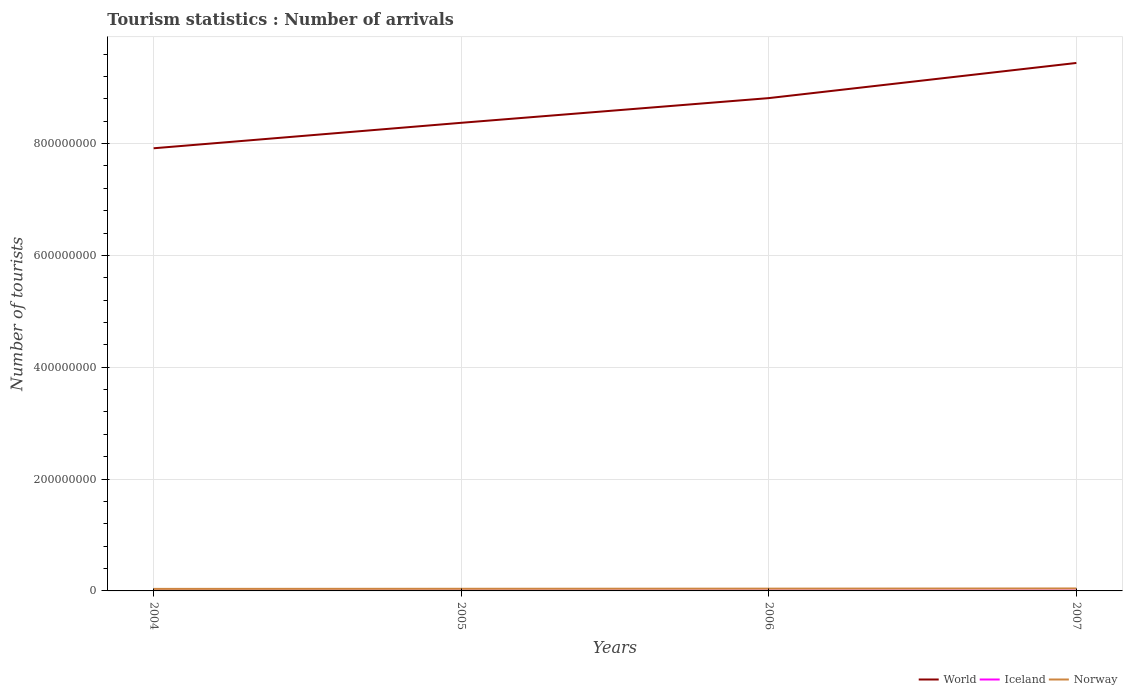How many different coloured lines are there?
Make the answer very short. 3. Across all years, what is the maximum number of tourist arrivals in Norway?
Your answer should be very brief. 3.63e+06. What is the total number of tourist arrivals in World in the graph?
Provide a succinct answer. -4.55e+07. What is the difference between the highest and the second highest number of tourist arrivals in Iceland?
Provide a short and direct response. 1.25e+05. Is the number of tourist arrivals in Iceland strictly greater than the number of tourist arrivals in World over the years?
Offer a very short reply. Yes. How many lines are there?
Offer a terse response. 3. How many years are there in the graph?
Provide a short and direct response. 4. What is the difference between two consecutive major ticks on the Y-axis?
Give a very brief answer. 2.00e+08. Are the values on the major ticks of Y-axis written in scientific E-notation?
Your answer should be very brief. No. Does the graph contain any zero values?
Make the answer very short. No. Where does the legend appear in the graph?
Ensure brevity in your answer.  Bottom right. How many legend labels are there?
Your response must be concise. 3. What is the title of the graph?
Provide a short and direct response. Tourism statistics : Number of arrivals. What is the label or title of the X-axis?
Your answer should be compact. Years. What is the label or title of the Y-axis?
Your response must be concise. Number of tourists. What is the Number of tourists in World in 2004?
Give a very brief answer. 7.92e+08. What is the Number of tourists in Norway in 2004?
Keep it short and to the point. 3.63e+06. What is the Number of tourists in World in 2005?
Your answer should be compact. 8.37e+08. What is the Number of tourists of Iceland in 2005?
Provide a succinct answer. 3.74e+05. What is the Number of tourists in Norway in 2005?
Offer a very short reply. 3.82e+06. What is the Number of tourists of World in 2006?
Ensure brevity in your answer.  8.81e+08. What is the Number of tourists of Iceland in 2006?
Make the answer very short. 4.22e+05. What is the Number of tourists of Norway in 2006?
Give a very brief answer. 4.07e+06. What is the Number of tourists of World in 2007?
Give a very brief answer. 9.44e+08. What is the Number of tourists in Iceland in 2007?
Your answer should be very brief. 4.85e+05. What is the Number of tourists in Norway in 2007?
Your answer should be compact. 4.38e+06. Across all years, what is the maximum Number of tourists of World?
Keep it short and to the point. 9.44e+08. Across all years, what is the maximum Number of tourists of Iceland?
Offer a very short reply. 4.85e+05. Across all years, what is the maximum Number of tourists in Norway?
Offer a terse response. 4.38e+06. Across all years, what is the minimum Number of tourists of World?
Offer a very short reply. 7.92e+08. Across all years, what is the minimum Number of tourists of Norway?
Offer a terse response. 3.63e+06. What is the total Number of tourists in World in the graph?
Give a very brief answer. 3.45e+09. What is the total Number of tourists of Iceland in the graph?
Give a very brief answer. 1.64e+06. What is the total Number of tourists in Norway in the graph?
Keep it short and to the point. 1.59e+07. What is the difference between the Number of tourists of World in 2004 and that in 2005?
Your answer should be compact. -4.55e+07. What is the difference between the Number of tourists of Iceland in 2004 and that in 2005?
Give a very brief answer. -1.40e+04. What is the difference between the Number of tourists of Norway in 2004 and that in 2005?
Ensure brevity in your answer.  -1.96e+05. What is the difference between the Number of tourists of World in 2004 and that in 2006?
Give a very brief answer. -8.97e+07. What is the difference between the Number of tourists of Iceland in 2004 and that in 2006?
Your answer should be compact. -6.20e+04. What is the difference between the Number of tourists in Norway in 2004 and that in 2006?
Provide a succinct answer. -4.42e+05. What is the difference between the Number of tourists in World in 2004 and that in 2007?
Make the answer very short. -1.53e+08. What is the difference between the Number of tourists in Iceland in 2004 and that in 2007?
Provide a succinct answer. -1.25e+05. What is the difference between the Number of tourists of Norway in 2004 and that in 2007?
Ensure brevity in your answer.  -7.49e+05. What is the difference between the Number of tourists in World in 2005 and that in 2006?
Give a very brief answer. -4.42e+07. What is the difference between the Number of tourists of Iceland in 2005 and that in 2006?
Ensure brevity in your answer.  -4.80e+04. What is the difference between the Number of tourists of Norway in 2005 and that in 2006?
Provide a short and direct response. -2.46e+05. What is the difference between the Number of tourists of World in 2005 and that in 2007?
Your answer should be very brief. -1.07e+08. What is the difference between the Number of tourists in Iceland in 2005 and that in 2007?
Provide a succinct answer. -1.11e+05. What is the difference between the Number of tourists of Norway in 2005 and that in 2007?
Ensure brevity in your answer.  -5.53e+05. What is the difference between the Number of tourists in World in 2006 and that in 2007?
Your response must be concise. -6.29e+07. What is the difference between the Number of tourists in Iceland in 2006 and that in 2007?
Ensure brevity in your answer.  -6.30e+04. What is the difference between the Number of tourists in Norway in 2006 and that in 2007?
Offer a very short reply. -3.07e+05. What is the difference between the Number of tourists in World in 2004 and the Number of tourists in Iceland in 2005?
Offer a very short reply. 7.91e+08. What is the difference between the Number of tourists of World in 2004 and the Number of tourists of Norway in 2005?
Give a very brief answer. 7.88e+08. What is the difference between the Number of tourists of Iceland in 2004 and the Number of tourists of Norway in 2005?
Provide a succinct answer. -3.46e+06. What is the difference between the Number of tourists of World in 2004 and the Number of tourists of Iceland in 2006?
Provide a short and direct response. 7.91e+08. What is the difference between the Number of tourists of World in 2004 and the Number of tourists of Norway in 2006?
Offer a very short reply. 7.88e+08. What is the difference between the Number of tourists of Iceland in 2004 and the Number of tourists of Norway in 2006?
Your answer should be very brief. -3.71e+06. What is the difference between the Number of tourists of World in 2004 and the Number of tourists of Iceland in 2007?
Your response must be concise. 7.91e+08. What is the difference between the Number of tourists in World in 2004 and the Number of tourists in Norway in 2007?
Keep it short and to the point. 7.87e+08. What is the difference between the Number of tourists in Iceland in 2004 and the Number of tourists in Norway in 2007?
Offer a very short reply. -4.02e+06. What is the difference between the Number of tourists in World in 2005 and the Number of tourists in Iceland in 2006?
Your answer should be compact. 8.37e+08. What is the difference between the Number of tourists of World in 2005 and the Number of tourists of Norway in 2006?
Give a very brief answer. 8.33e+08. What is the difference between the Number of tourists of Iceland in 2005 and the Number of tourists of Norway in 2006?
Make the answer very short. -3.70e+06. What is the difference between the Number of tourists of World in 2005 and the Number of tourists of Iceland in 2007?
Offer a terse response. 8.37e+08. What is the difference between the Number of tourists in World in 2005 and the Number of tourists in Norway in 2007?
Make the answer very short. 8.33e+08. What is the difference between the Number of tourists of Iceland in 2005 and the Number of tourists of Norway in 2007?
Offer a very short reply. -4.00e+06. What is the difference between the Number of tourists in World in 2006 and the Number of tourists in Iceland in 2007?
Offer a very short reply. 8.81e+08. What is the difference between the Number of tourists of World in 2006 and the Number of tourists of Norway in 2007?
Provide a short and direct response. 8.77e+08. What is the difference between the Number of tourists in Iceland in 2006 and the Number of tourists in Norway in 2007?
Give a very brief answer. -3.96e+06. What is the average Number of tourists in World per year?
Offer a very short reply. 8.64e+08. What is the average Number of tourists of Iceland per year?
Provide a succinct answer. 4.10e+05. What is the average Number of tourists in Norway per year?
Provide a succinct answer. 3.97e+06. In the year 2004, what is the difference between the Number of tourists in World and Number of tourists in Iceland?
Give a very brief answer. 7.91e+08. In the year 2004, what is the difference between the Number of tourists of World and Number of tourists of Norway?
Your answer should be very brief. 7.88e+08. In the year 2004, what is the difference between the Number of tourists of Iceland and Number of tourists of Norway?
Your answer should be compact. -3.27e+06. In the year 2005, what is the difference between the Number of tourists of World and Number of tourists of Iceland?
Offer a very short reply. 8.37e+08. In the year 2005, what is the difference between the Number of tourists of World and Number of tourists of Norway?
Keep it short and to the point. 8.33e+08. In the year 2005, what is the difference between the Number of tourists in Iceland and Number of tourists in Norway?
Provide a succinct answer. -3.45e+06. In the year 2006, what is the difference between the Number of tourists of World and Number of tourists of Iceland?
Ensure brevity in your answer.  8.81e+08. In the year 2006, what is the difference between the Number of tourists of World and Number of tourists of Norway?
Offer a very short reply. 8.77e+08. In the year 2006, what is the difference between the Number of tourists of Iceland and Number of tourists of Norway?
Your response must be concise. -3.65e+06. In the year 2007, what is the difference between the Number of tourists of World and Number of tourists of Iceland?
Give a very brief answer. 9.44e+08. In the year 2007, what is the difference between the Number of tourists of World and Number of tourists of Norway?
Give a very brief answer. 9.40e+08. In the year 2007, what is the difference between the Number of tourists in Iceland and Number of tourists in Norway?
Provide a succinct answer. -3.89e+06. What is the ratio of the Number of tourists of World in 2004 to that in 2005?
Give a very brief answer. 0.95. What is the ratio of the Number of tourists of Iceland in 2004 to that in 2005?
Your answer should be very brief. 0.96. What is the ratio of the Number of tourists in Norway in 2004 to that in 2005?
Your answer should be compact. 0.95. What is the ratio of the Number of tourists of World in 2004 to that in 2006?
Give a very brief answer. 0.9. What is the ratio of the Number of tourists of Iceland in 2004 to that in 2006?
Your answer should be compact. 0.85. What is the ratio of the Number of tourists in Norway in 2004 to that in 2006?
Give a very brief answer. 0.89. What is the ratio of the Number of tourists in World in 2004 to that in 2007?
Keep it short and to the point. 0.84. What is the ratio of the Number of tourists of Iceland in 2004 to that in 2007?
Your response must be concise. 0.74. What is the ratio of the Number of tourists of Norway in 2004 to that in 2007?
Your answer should be compact. 0.83. What is the ratio of the Number of tourists of World in 2005 to that in 2006?
Give a very brief answer. 0.95. What is the ratio of the Number of tourists of Iceland in 2005 to that in 2006?
Offer a very short reply. 0.89. What is the ratio of the Number of tourists of Norway in 2005 to that in 2006?
Keep it short and to the point. 0.94. What is the ratio of the Number of tourists in World in 2005 to that in 2007?
Make the answer very short. 0.89. What is the ratio of the Number of tourists in Iceland in 2005 to that in 2007?
Give a very brief answer. 0.77. What is the ratio of the Number of tourists of Norway in 2005 to that in 2007?
Offer a terse response. 0.87. What is the ratio of the Number of tourists in World in 2006 to that in 2007?
Offer a terse response. 0.93. What is the ratio of the Number of tourists of Iceland in 2006 to that in 2007?
Your answer should be compact. 0.87. What is the ratio of the Number of tourists in Norway in 2006 to that in 2007?
Your response must be concise. 0.93. What is the difference between the highest and the second highest Number of tourists of World?
Offer a terse response. 6.29e+07. What is the difference between the highest and the second highest Number of tourists in Iceland?
Keep it short and to the point. 6.30e+04. What is the difference between the highest and the second highest Number of tourists in Norway?
Offer a terse response. 3.07e+05. What is the difference between the highest and the lowest Number of tourists in World?
Provide a short and direct response. 1.53e+08. What is the difference between the highest and the lowest Number of tourists of Iceland?
Offer a very short reply. 1.25e+05. What is the difference between the highest and the lowest Number of tourists of Norway?
Your response must be concise. 7.49e+05. 